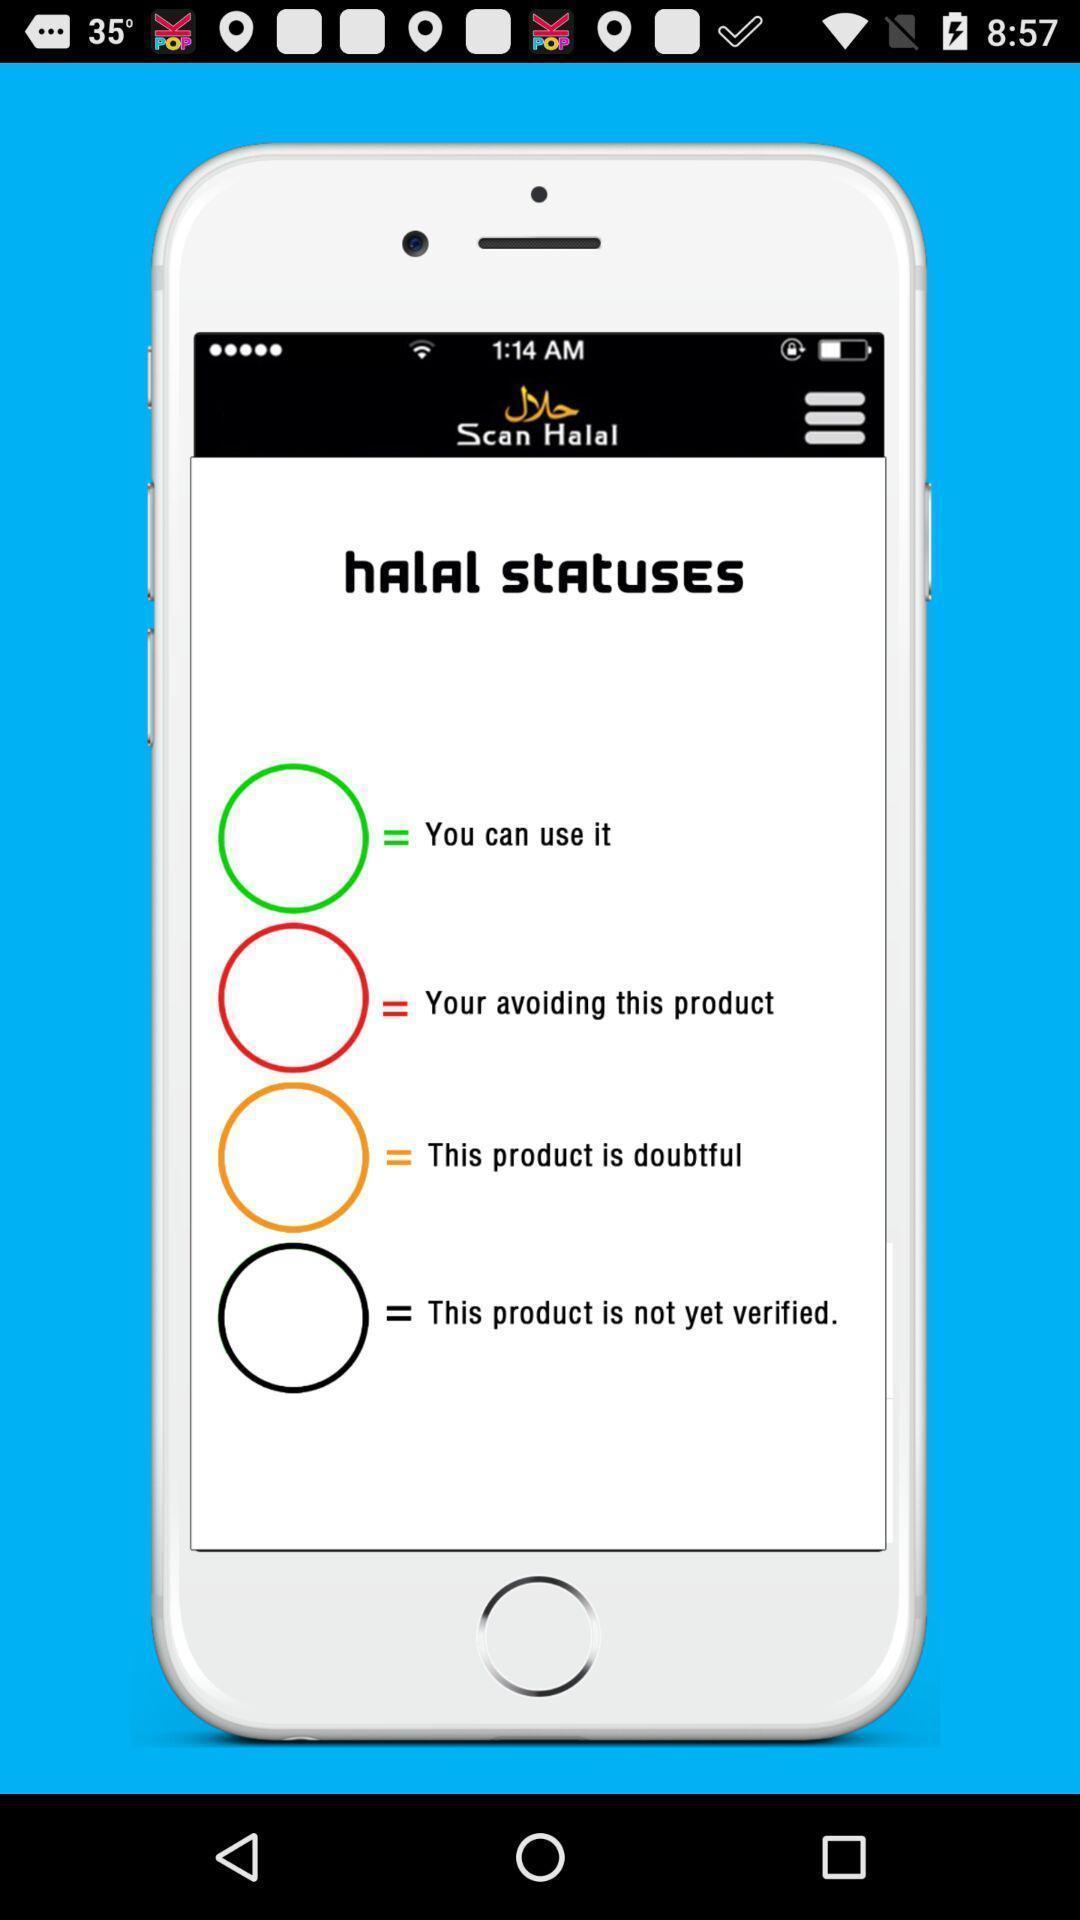What can you discern from this picture? List of options in the halal statuses. 